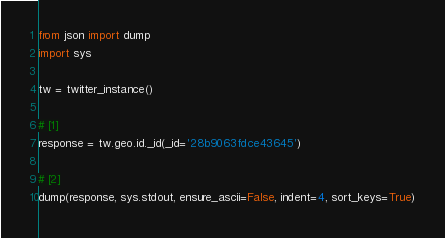<code> <loc_0><loc_0><loc_500><loc_500><_Python_>from json import dump
import sys

tw = twitter_instance()

# [1]
response = tw.geo.id._id(_id='28b9063fdce43645')

# [2]
dump(response, sys.stdout, ensure_ascii=False, indent=4, sort_keys=True)
</code> 